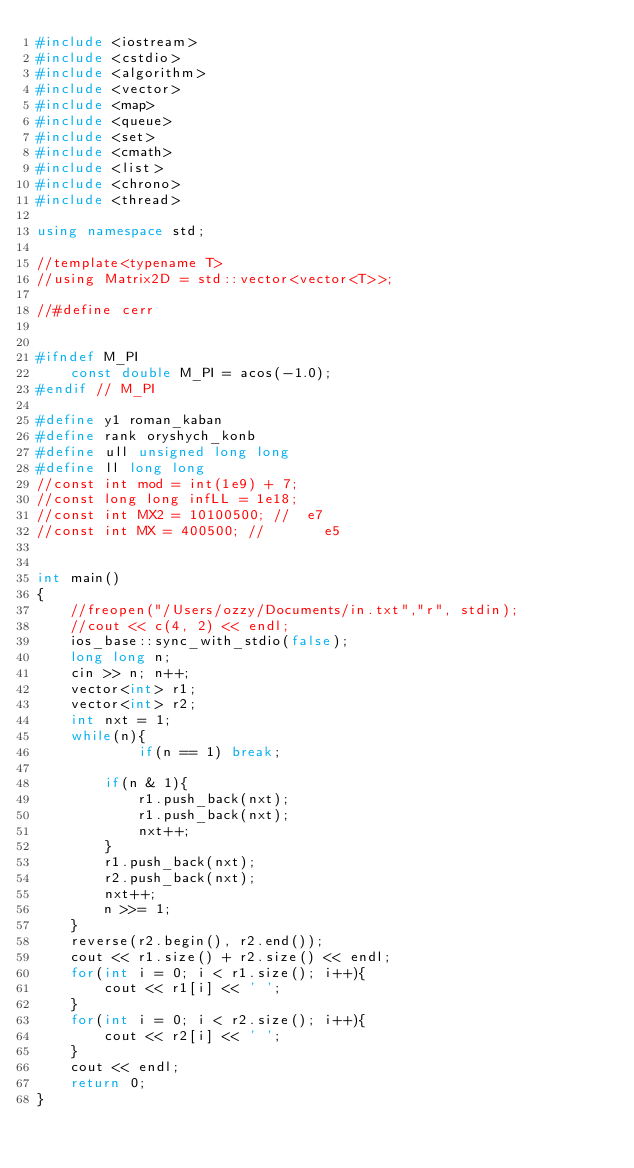Convert code to text. <code><loc_0><loc_0><loc_500><loc_500><_C++_>#include <iostream>
#include <cstdio>
#include <algorithm>
#include <vector>
#include <map>
#include <queue>
#include <set>
#include <cmath>
#include <list>
#include <chrono>
#include <thread>

using namespace std;

//template<typename T>
//using Matrix2D = std::vector<vector<T>>;

//#define cerr


#ifndef M_PI
    const double M_PI = acos(-1.0);
#endif // M_PI

#define y1 roman_kaban
#define rank oryshych_konb
#define ull unsigned long long
#define ll long long
//const int mod = int(1e9) + 7;
//const long long infLL = 1e18;
//const int MX2 = 10100500; //  e7
//const int MX = 400500; //       e5


int main()
{
    //freopen("/Users/ozzy/Documents/in.txt","r", stdin);
    //cout << c(4, 2) << endl;
    ios_base::sync_with_stdio(false);
    long long n;
    cin >> n; n++;
    vector<int> r1;
    vector<int> r2;
    int nxt = 1;
    while(n){
            if(n == 1) break;

        if(n & 1){
            r1.push_back(nxt);
            r1.push_back(nxt);
            nxt++;
        }
        r1.push_back(nxt);
        r2.push_back(nxt);
        nxt++;
        n >>= 1;
    }
    reverse(r2.begin(), r2.end());
    cout << r1.size() + r2.size() << endl;
    for(int i = 0; i < r1.size(); i++){
        cout << r1[i] << ' ';
    }
    for(int i = 0; i < r2.size(); i++){
        cout << r2[i] << ' ';
    }
    cout << endl;
    return 0;
}
</code> 